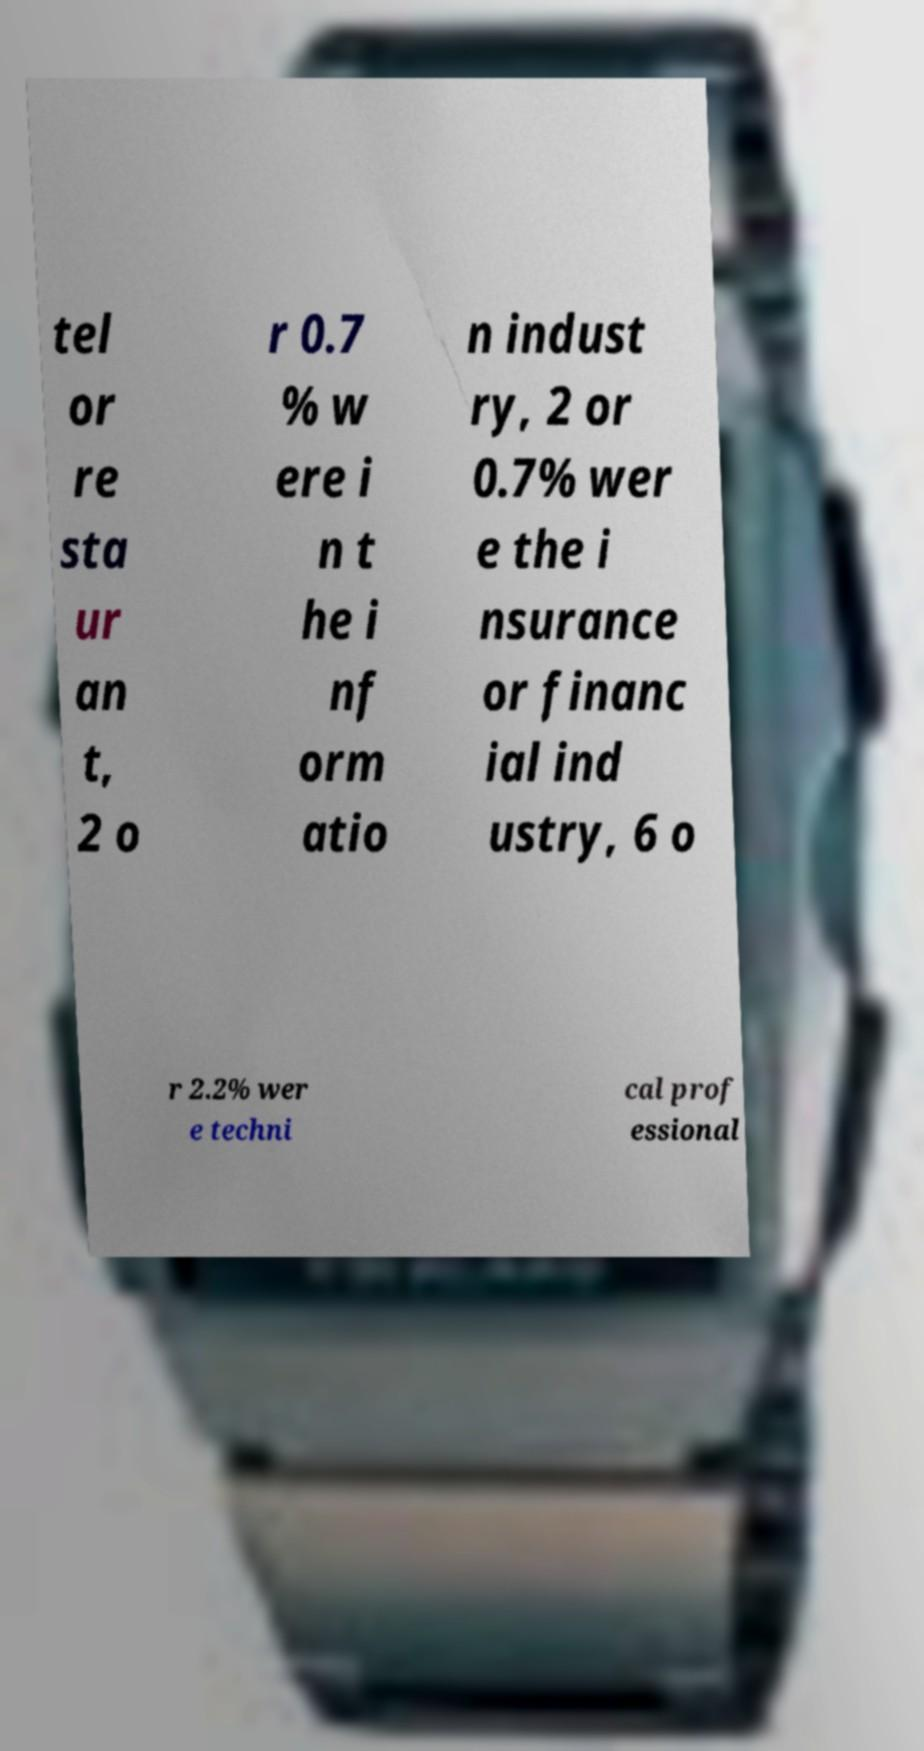What messages or text are displayed in this image? I need them in a readable, typed format. tel or re sta ur an t, 2 o r 0.7 % w ere i n t he i nf orm atio n indust ry, 2 or 0.7% wer e the i nsurance or financ ial ind ustry, 6 o r 2.2% wer e techni cal prof essional 